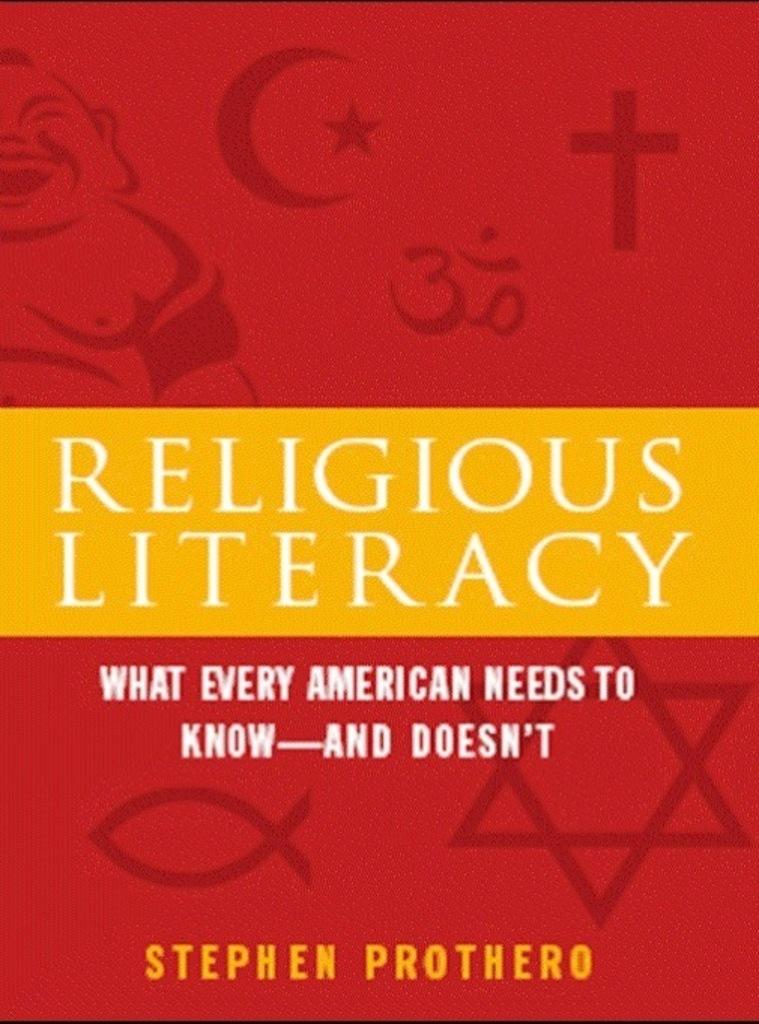Who wrote this book?
Provide a succinct answer. Stephen prothero. Who wrote this book?
Your answer should be compact. Stephen prothero. 